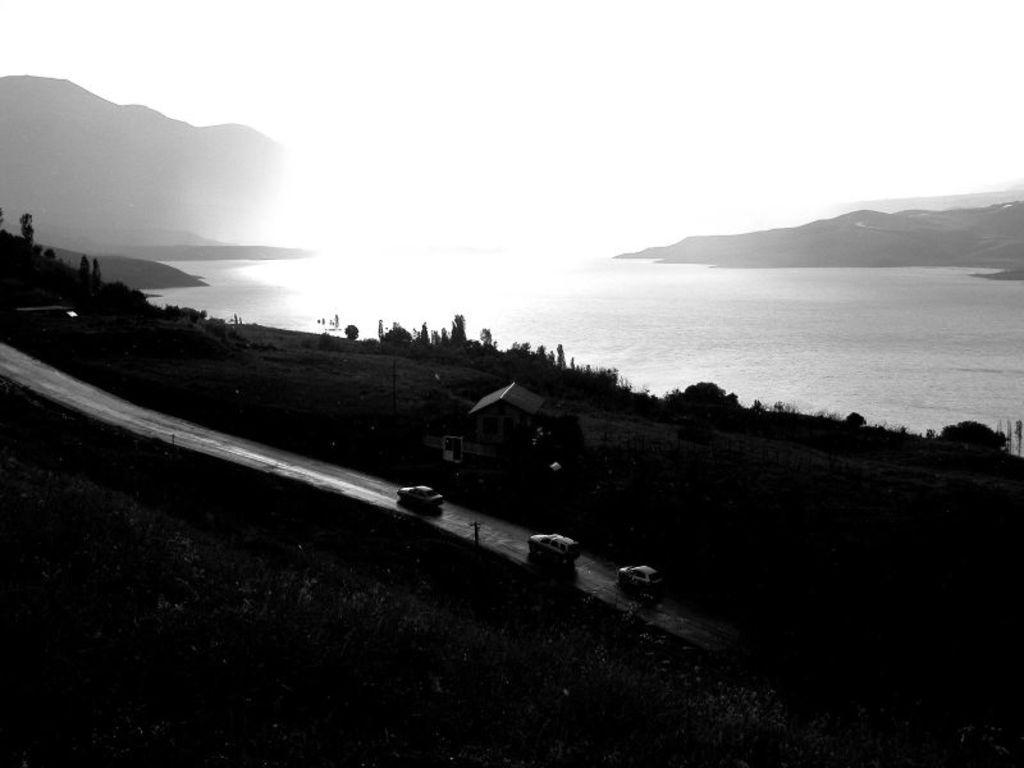How would you summarize this image in a sentence or two? In this picture there are cars and greenery at the bottom side of the image and there is sea at the top side of the image. 